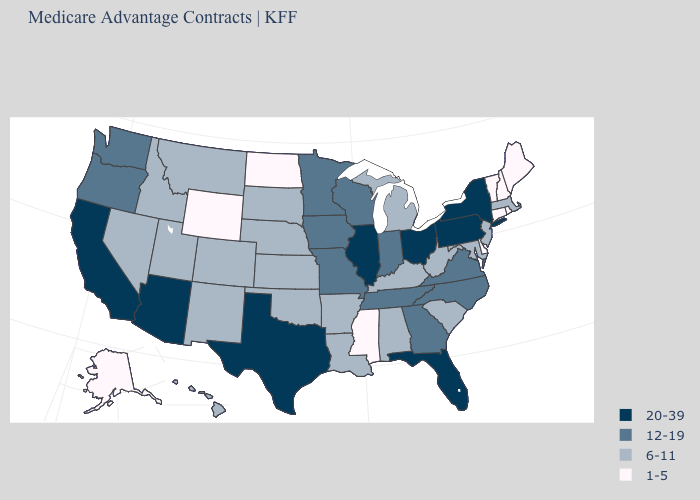What is the value of Delaware?
Quick response, please. 1-5. What is the highest value in the USA?
Write a very short answer. 20-39. Is the legend a continuous bar?
Keep it brief. No. Name the states that have a value in the range 12-19?
Concise answer only. Georgia, Iowa, Indiana, Minnesota, Missouri, North Carolina, Oregon, Tennessee, Virginia, Washington, Wisconsin. Which states have the lowest value in the USA?
Be succinct. Alaska, Connecticut, Delaware, Maine, Mississippi, North Dakota, New Hampshire, Rhode Island, Vermont, Wyoming. Does Georgia have the same value as Indiana?
Be succinct. Yes. Does Maryland have the same value as Rhode Island?
Short answer required. No. Is the legend a continuous bar?
Write a very short answer. No. How many symbols are there in the legend?
Answer briefly. 4. Among the states that border North Dakota , does Minnesota have the highest value?
Short answer required. Yes. What is the highest value in the USA?
Short answer required. 20-39. What is the value of Tennessee?
Quick response, please. 12-19. What is the value of South Dakota?
Concise answer only. 6-11. Name the states that have a value in the range 1-5?
Short answer required. Alaska, Connecticut, Delaware, Maine, Mississippi, North Dakota, New Hampshire, Rhode Island, Vermont, Wyoming. Which states have the highest value in the USA?
Answer briefly. Arizona, California, Florida, Illinois, New York, Ohio, Pennsylvania, Texas. 